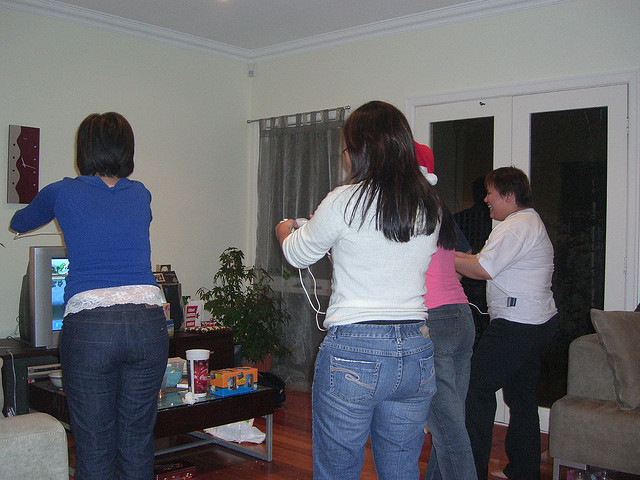Can you describe the setting of the image? The photo captures a group of people in a homey living room with a television, couch, and coffee table. Personal belongings and refreshments are scattered around, contributing to a casual and friendly atmosphere. 